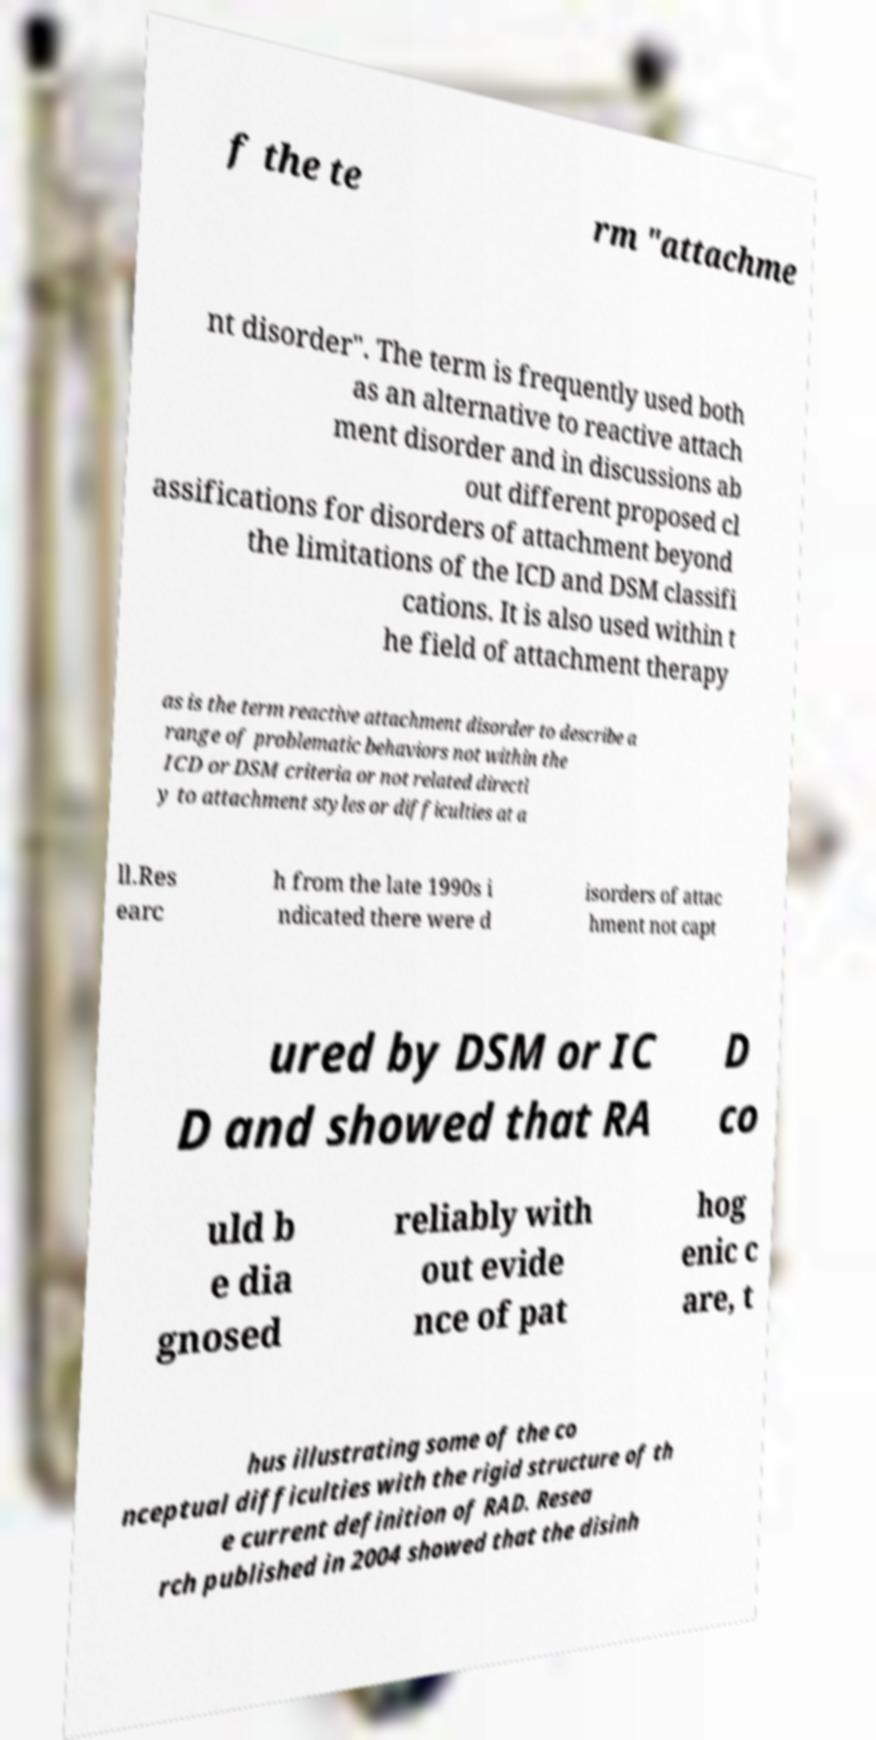Can you read and provide the text displayed in the image?This photo seems to have some interesting text. Can you extract and type it out for me? f the te rm "attachme nt disorder". The term is frequently used both as an alternative to reactive attach ment disorder and in discussions ab out different proposed cl assifications for disorders of attachment beyond the limitations of the ICD and DSM classifi cations. It is also used within t he field of attachment therapy as is the term reactive attachment disorder to describe a range of problematic behaviors not within the ICD or DSM criteria or not related directl y to attachment styles or difficulties at a ll.Res earc h from the late 1990s i ndicated there were d isorders of attac hment not capt ured by DSM or IC D and showed that RA D co uld b e dia gnosed reliably with out evide nce of pat hog enic c are, t hus illustrating some of the co nceptual difficulties with the rigid structure of th e current definition of RAD. Resea rch published in 2004 showed that the disinh 